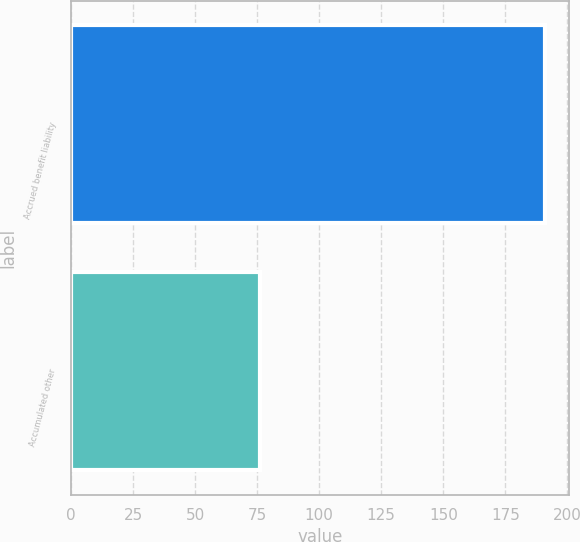<chart> <loc_0><loc_0><loc_500><loc_500><bar_chart><fcel>Accrued benefit liability<fcel>Accumulated other<nl><fcel>191<fcel>76<nl></chart> 